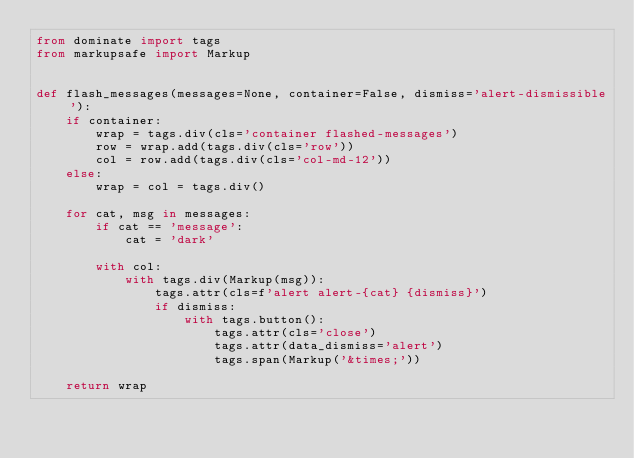<code> <loc_0><loc_0><loc_500><loc_500><_Python_>from dominate import tags
from markupsafe import Markup


def flash_messages(messages=None, container=False, dismiss='alert-dismissible'):
    if container:
        wrap = tags.div(cls='container flashed-messages')
        row = wrap.add(tags.div(cls='row'))
        col = row.add(tags.div(cls='col-md-12'))
    else:
        wrap = col = tags.div()

    for cat, msg in messages:
        if cat == 'message':
            cat = 'dark'

        with col:
            with tags.div(Markup(msg)):
                tags.attr(cls=f'alert alert-{cat} {dismiss}')
                if dismiss:
                    with tags.button():
                        tags.attr(cls='close')
                        tags.attr(data_dismiss='alert')
                        tags.span(Markup('&times;'))

    return wrap
</code> 